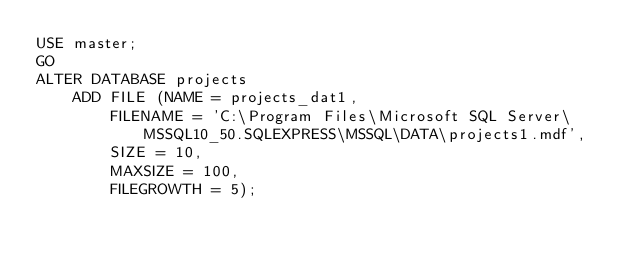Convert code to text. <code><loc_0><loc_0><loc_500><loc_500><_SQL_>USE master;
GO
ALTER DATABASE projects
	ADD FILE (NAME = projects_dat1,
		FILENAME = 'C:\Program Files\Microsoft SQL Server\MSSQL10_50.SQLEXPRESS\MSSQL\DATA\projects1.mdf',
		SIZE = 10,
		MAXSIZE = 100,
		FILEGROWTH = 5);</code> 